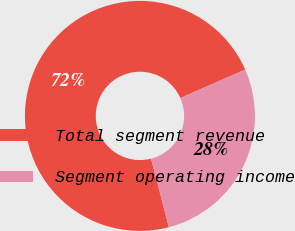Convert chart to OTSL. <chart><loc_0><loc_0><loc_500><loc_500><pie_chart><fcel>Total segment revenue<fcel>Segment operating income<nl><fcel>72.45%<fcel>27.55%<nl></chart> 